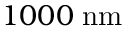<formula> <loc_0><loc_0><loc_500><loc_500>1 0 0 0 \, n m</formula> 